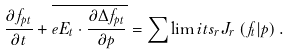<formula> <loc_0><loc_0><loc_500><loc_500>\frac { \partial f _ { p t } } { \partial t } + \overline { e { E } _ { t } \cdot \frac { \partial \Delta f _ { { p } t } } { \partial { p } } } = \sum \lim i t s _ { r } J _ { r } \left ( f _ { t } | p \right ) .</formula> 